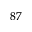Convert formula to latex. <formula><loc_0><loc_0><loc_500><loc_500>^ { 8 7 }</formula> 